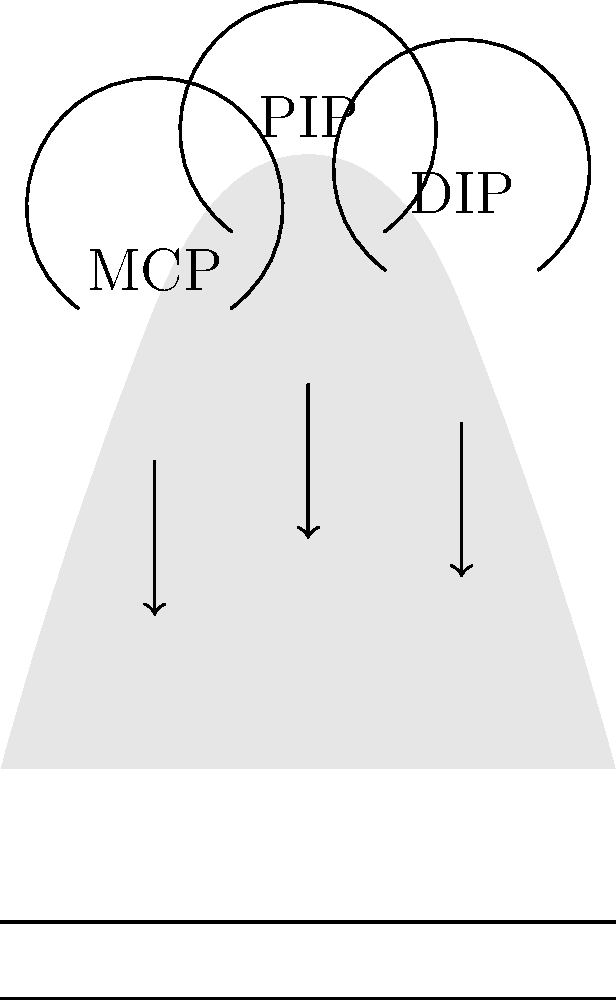While typing on a keyboard, which joint in the fingers experiences the greatest range of motion, and how does this relate to the efficiency of typing for a content creator hosting virtual workshops? To answer this question, let's break down the biomechanics of finger movement during typing:

1. The human hand has three main joints in each finger:
   a) Metacarpophalangeal (MCP) joint: connects the finger to the hand
   b) Proximal Interphalangeal (PIP) joint: the middle joint of the finger
   c) Distal Interphalangeal (DIP) joint: the joint closest to the fingertip

2. During typing:
   - The MCP joint allows for flexion (bending) and extension (straightening) of the finger, as well as some lateral movement.
   - The PIP joint primarily allows for flexion and extension.
   - The DIP joint also allows for flexion and extension, but to a lesser degree than the PIP joint.

3. Range of motion:
   - MCP joint: approximately 90° of flexion and 30-40° of extension
   - PIP joint: approximately 100-110° of flexion and 0° of extension
   - DIP joint: approximately 70-80° of flexion and 0° of extension

4. The PIP joint has the greatest range of motion, allowing for the most significant finger curl when pressing keys.

5. For a content creator hosting virtual workshops:
   - Efficient typing is crucial for real-time interaction and content creation.
   - The greater range of motion in the PIP joint allows for faster and more precise key presses.
   - This increased efficiency can lead to improved typing speed and accuracy, enhancing the overall quality of virtual workshops and content creation.

6. The biomechanics of finger movement during typing directly impact the content creator's ability to:
   - Respond quickly to participants' questions
   - Take notes or create content in real-time
   - Manage multiple tasks simultaneously during virtual workshops

Therefore, the PIP joint experiences the greatest range of motion during typing, which contributes significantly to typing efficiency for a content creator hosting virtual workshops.
Answer: The Proximal Interphalangeal (PIP) joint; it allows for efficient and precise key presses, enhancing typing speed and accuracy for virtual workshop hosting. 